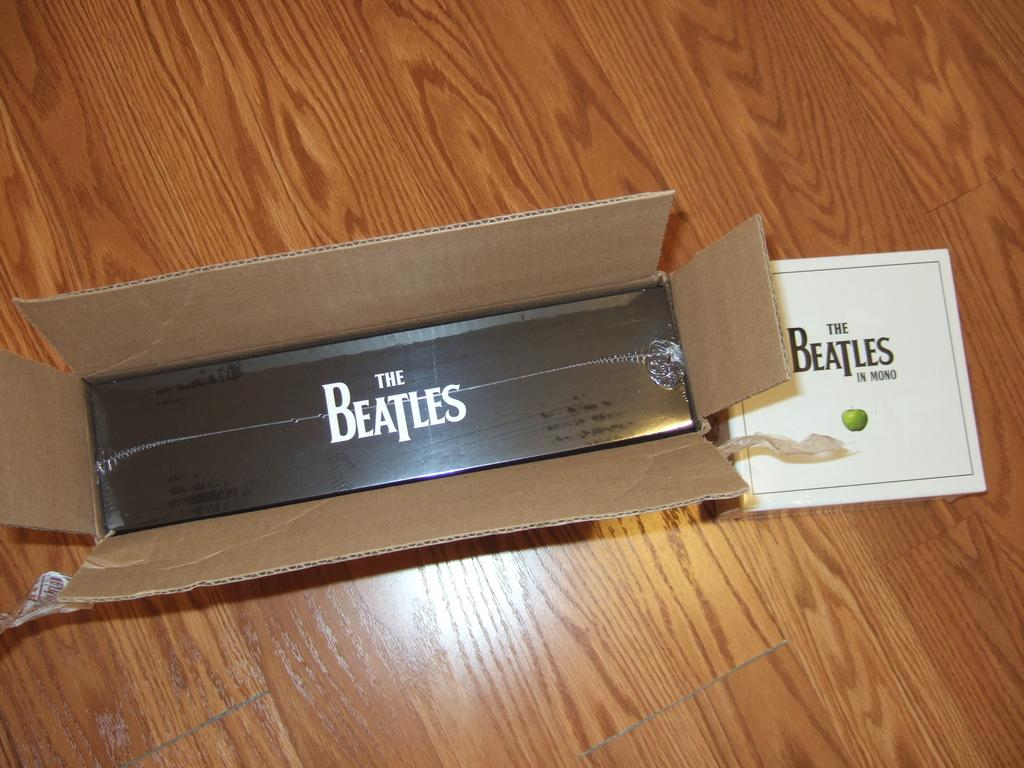<image>
Provide a brief description of the given image. A cardboard box containing albums of the Beatles - "The Beatles in Mono" 